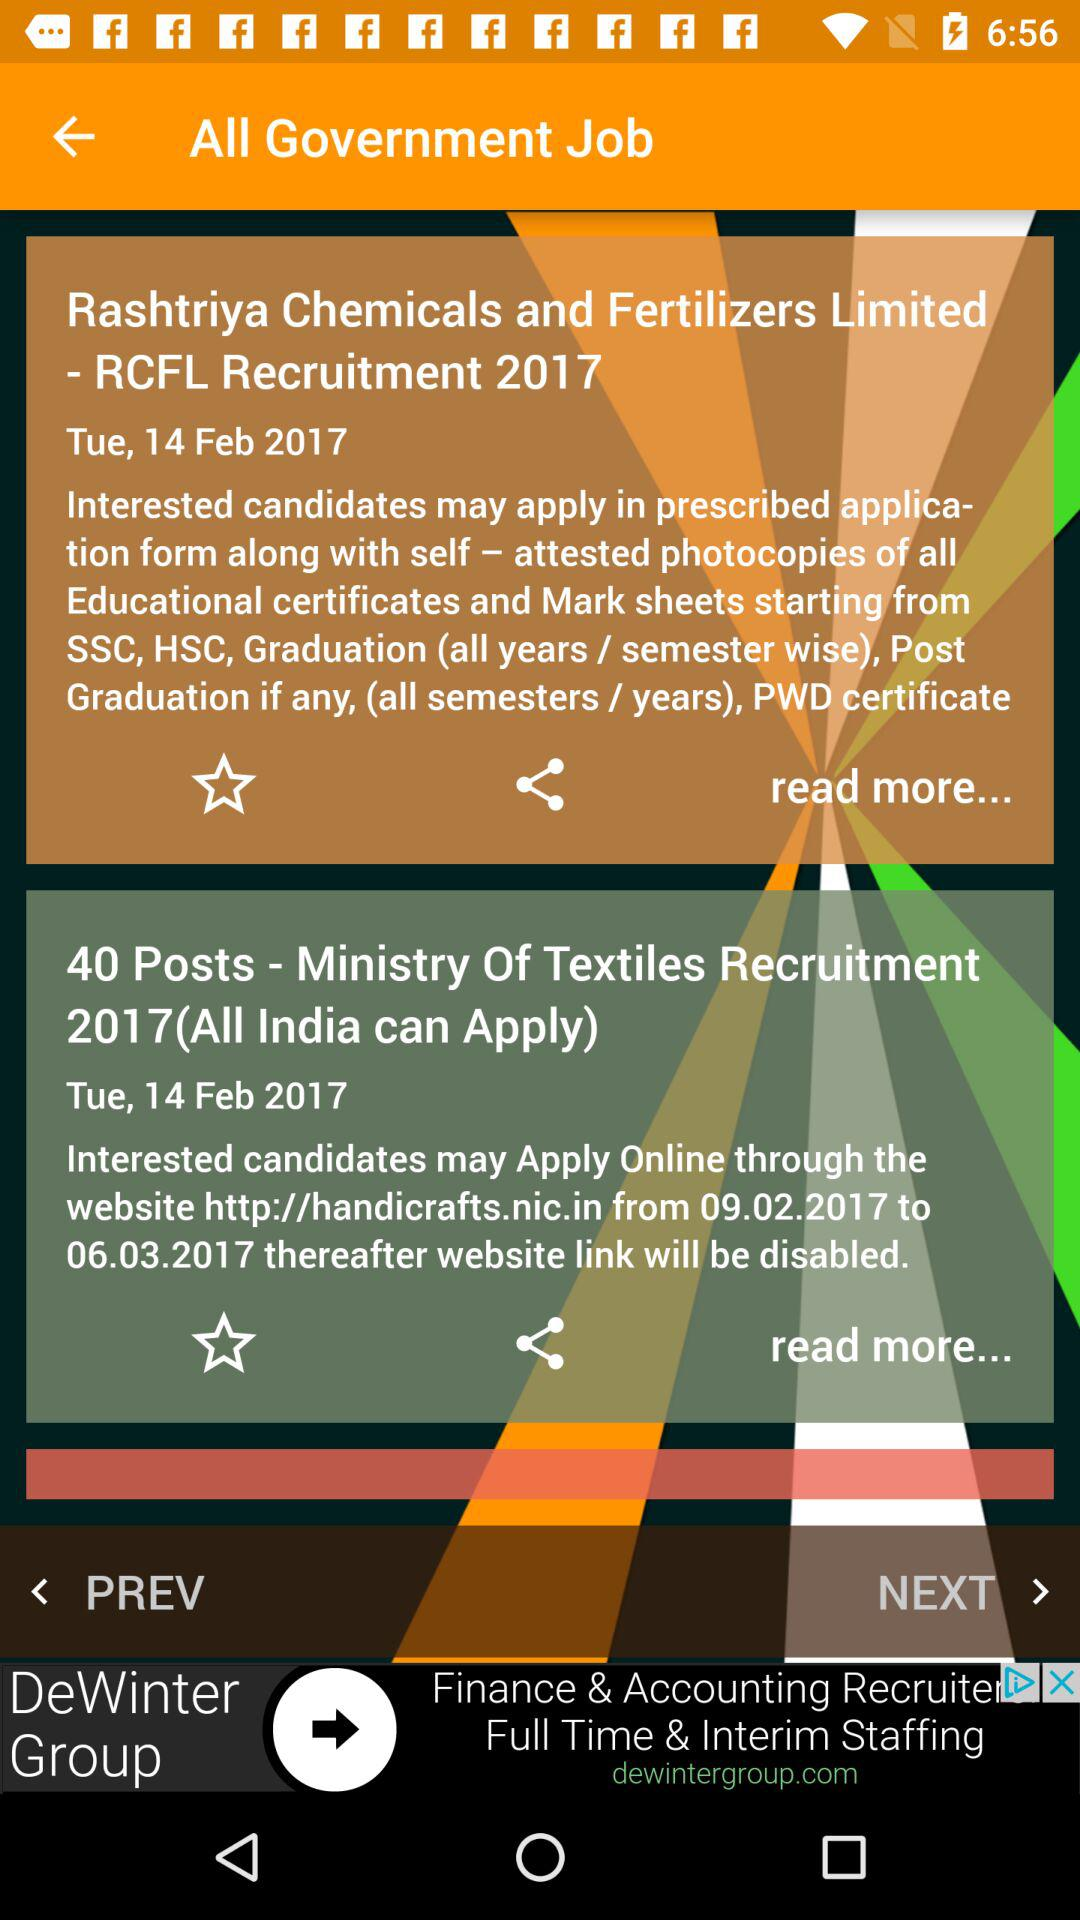On which date was the article published? The article was published on Tuesday, February 14, 2017. 